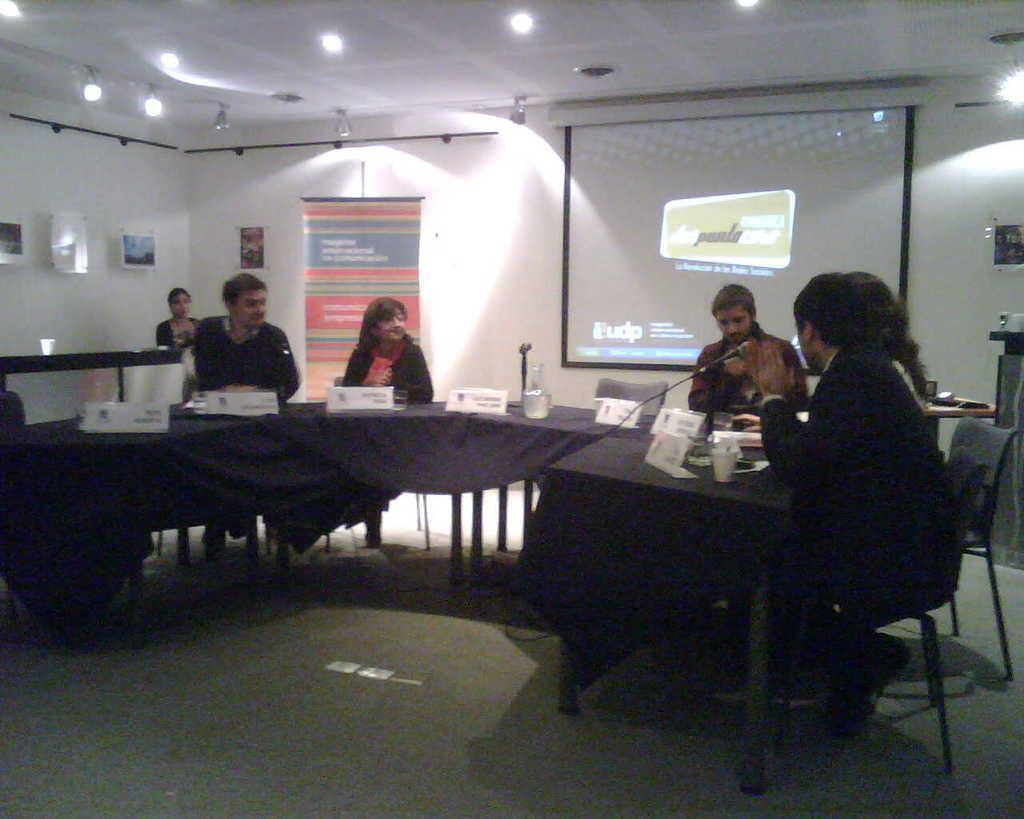Describe this image in one or two sentences. This is an image clicked inside the room. Here i can see few people are sitting on the chairs around the table which is covered with a blue cloth. On the table I can see few name board and glasses. In the background there is a screen is attached to the wall and also few frames are there. It is looking like a meeting hall. On the top of the image there are few lights. 